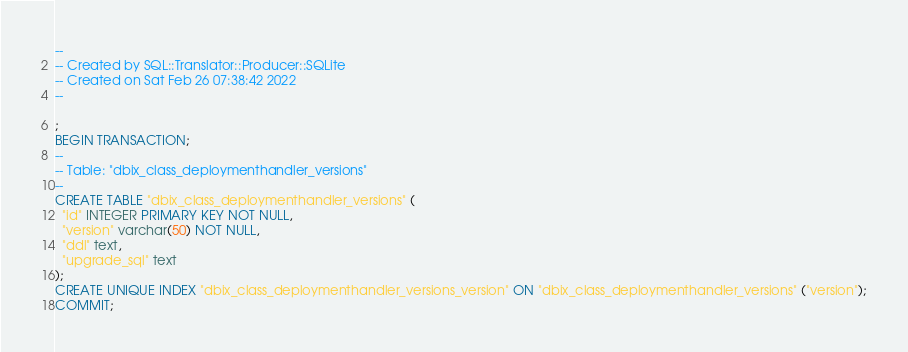Convert code to text. <code><loc_0><loc_0><loc_500><loc_500><_SQL_>--
-- Created by SQL::Translator::Producer::SQLite
-- Created on Sat Feb 26 07:38:42 2022
--

;
BEGIN TRANSACTION;
--
-- Table: "dbix_class_deploymenthandler_versions"
--
CREATE TABLE "dbix_class_deploymenthandler_versions" (
  "id" INTEGER PRIMARY KEY NOT NULL,
  "version" varchar(50) NOT NULL,
  "ddl" text,
  "upgrade_sql" text
);
CREATE UNIQUE INDEX "dbix_class_deploymenthandler_versions_version" ON "dbix_class_deploymenthandler_versions" ("version");
COMMIT;
</code> 